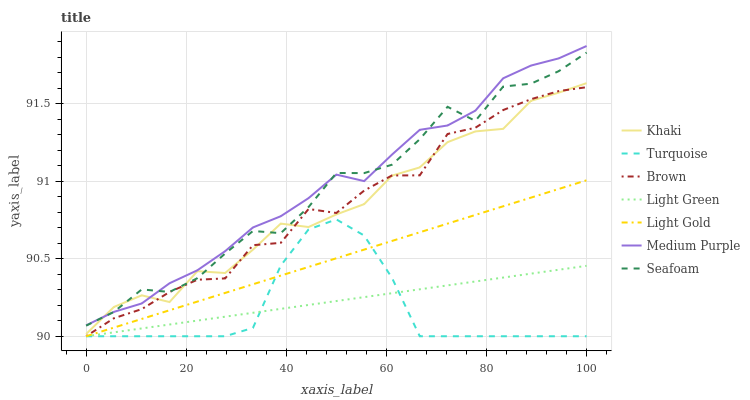Does Turquoise have the minimum area under the curve?
Answer yes or no. Yes. Does Medium Purple have the maximum area under the curve?
Answer yes or no. Yes. Does Khaki have the minimum area under the curve?
Answer yes or no. No. Does Khaki have the maximum area under the curve?
Answer yes or no. No. Is Light Green the smoothest?
Answer yes or no. Yes. Is Seafoam the roughest?
Answer yes or no. Yes. Is Turquoise the smoothest?
Answer yes or no. No. Is Turquoise the roughest?
Answer yes or no. No. Does Brown have the lowest value?
Answer yes or no. Yes. Does Khaki have the lowest value?
Answer yes or no. No. Does Medium Purple have the highest value?
Answer yes or no. Yes. Does Turquoise have the highest value?
Answer yes or no. No. Is Turquoise less than Khaki?
Answer yes or no. Yes. Is Medium Purple greater than Light Green?
Answer yes or no. Yes. Does Medium Purple intersect Khaki?
Answer yes or no. Yes. Is Medium Purple less than Khaki?
Answer yes or no. No. Is Medium Purple greater than Khaki?
Answer yes or no. No. Does Turquoise intersect Khaki?
Answer yes or no. No. 